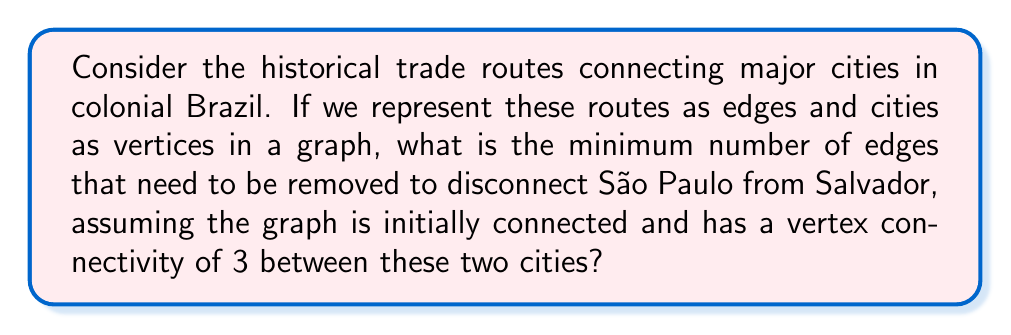Can you answer this question? To approach this problem, we need to understand some key concepts from graph theory and topology:

1. Vertex connectivity: This is the minimum number of vertices that need to be removed to disconnect a graph. In our case, it's given as 3 between São Paulo and Salvador.

2. Edge connectivity: This is the minimum number of edges that need to be removed to disconnect a graph. It's always less than or equal to the vertex connectivity.

3. Menger's theorem: This states that the maximum number of edge-disjoint paths between two vertices is equal to the minimum number of edges that need to be removed to disconnect those vertices.

Given that the vertex connectivity between São Paulo and Salvador is 3, we can deduce:

$$\text{edge connectivity} \leq \text{vertex connectivity} = 3$$

By Menger's theorem, there are exactly 3 edge-disjoint paths between São Paulo and Salvador. To disconnect these cities, we need to remove at least one edge from each of these paths.

Therefore, the minimum number of edges that need to be removed is equal to the edge connectivity, which is 3.

This topological analysis provides insights into the resilience of historical trade networks in colonial Brazil, showing how well-connected major cities like São Paulo and Salvador were, and how many alternative routes existed between them.
Answer: 3 edges 